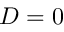<formula> <loc_0><loc_0><loc_500><loc_500>D = 0</formula> 